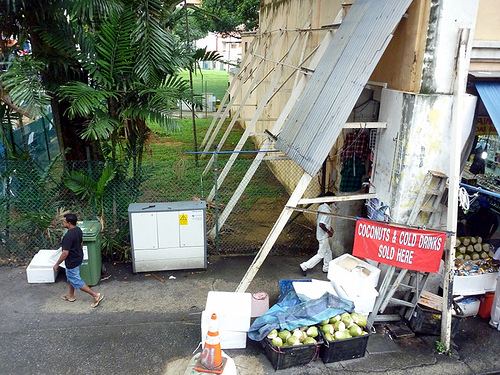<image>
Is there a men behind the men? Yes. From this viewpoint, the men is positioned behind the men, with the men partially or fully occluding the men. Is the fence behind the man? Yes. From this viewpoint, the fence is positioned behind the man, with the man partially or fully occluding the fence. 